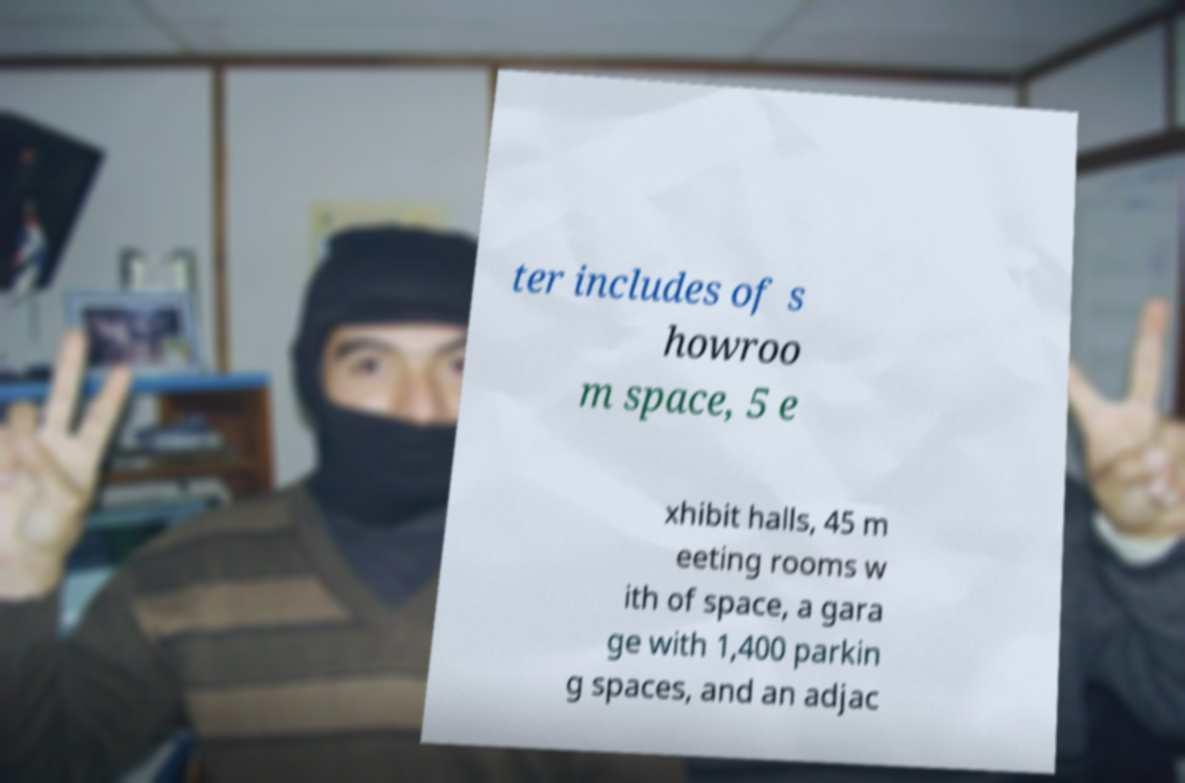Could you assist in decoding the text presented in this image and type it out clearly? ter includes of s howroo m space, 5 e xhibit halls, 45 m eeting rooms w ith of space, a gara ge with 1,400 parkin g spaces, and an adjac 